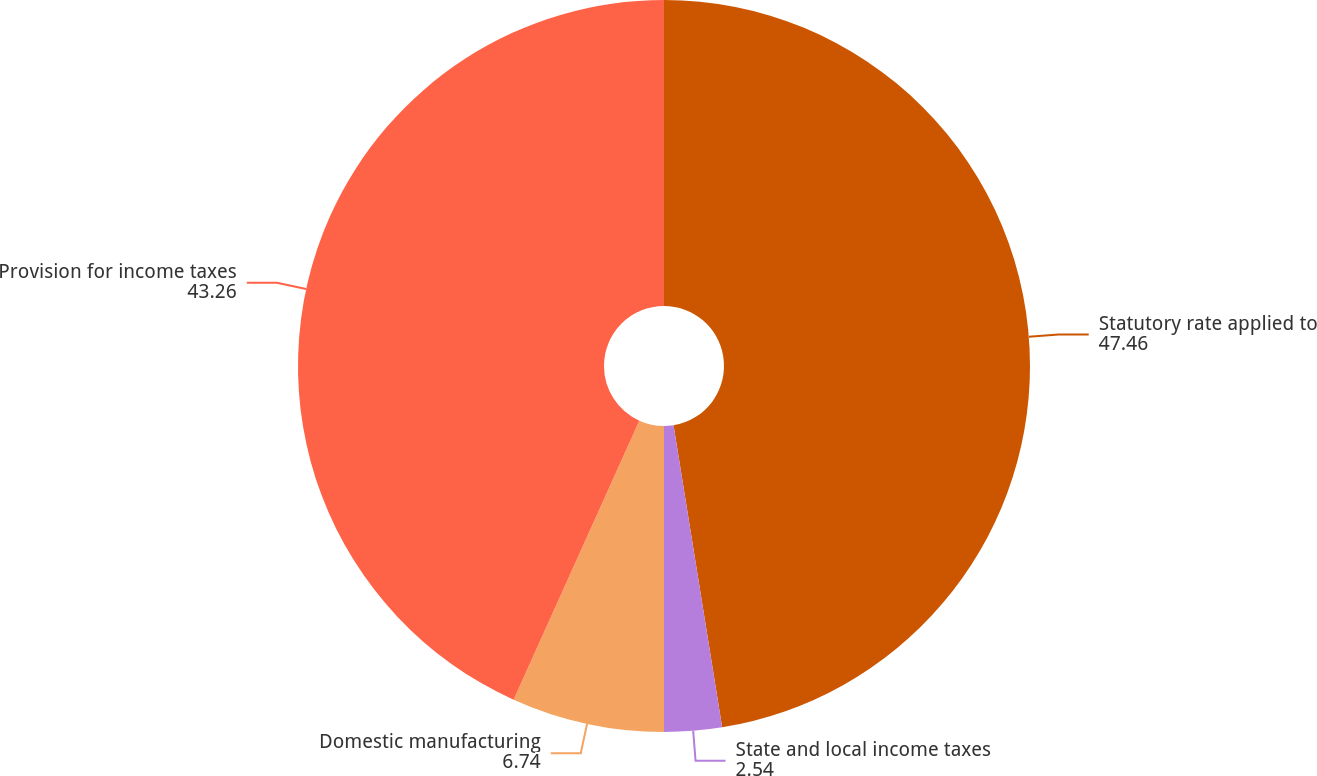Convert chart to OTSL. <chart><loc_0><loc_0><loc_500><loc_500><pie_chart><fcel>Statutory rate applied to<fcel>State and local income taxes<fcel>Domestic manufacturing<fcel>Provision for income taxes<nl><fcel>47.46%<fcel>2.54%<fcel>6.74%<fcel>43.26%<nl></chart> 